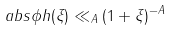Convert formula to latex. <formula><loc_0><loc_0><loc_500><loc_500>\ a b s { \phi h ( \xi ) } \ll _ { A } ( 1 + \| \xi \| ) ^ { - A }</formula> 